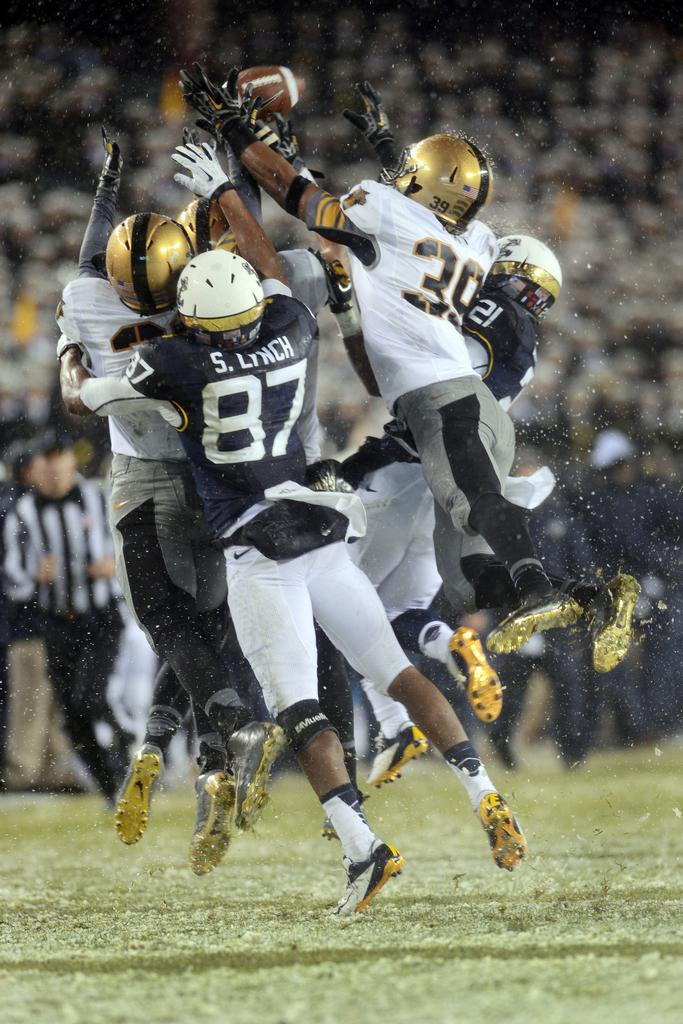What are the players in the image doing? The players are jumping to catch a ball. What is the ball's current position in the image? The ball is in the air. Can you describe the people in the background of the image? There are spectators in the background of the image. What type of disgust can be seen on the players' faces as they jump to catch the ball? There is no indication of disgust on the players' faces in the image; they appear focused on catching the ball. What is in the pocket of the player in the image? There is no mention of a pocket or any object in a pocket in the image. 